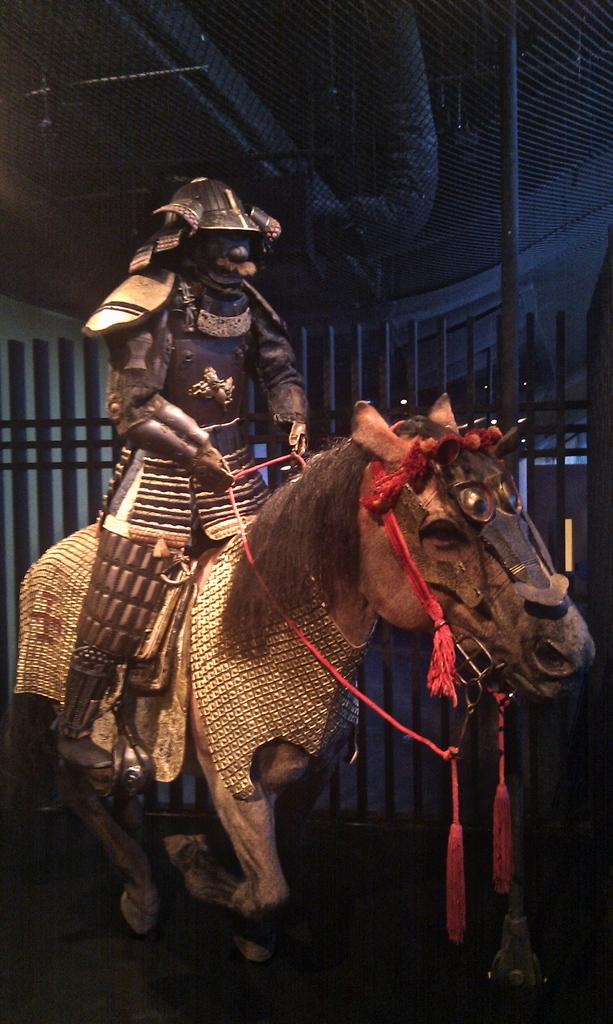What is the main subject of the image? There is a statue of a person sitting on a statue of a horse in the image. What can be seen in the background of the image? There is fencing in the background of the image. What other objects are present in the image? There is a pole and a net visible in the image. What type of nerve can be seen in the image? There are no nerves present in the image; it features statues and other inanimate objects. What type of muscle is depicted in the statue? There are no muscles depicted in the statue, as it is a sculpture made of inanimate material. 